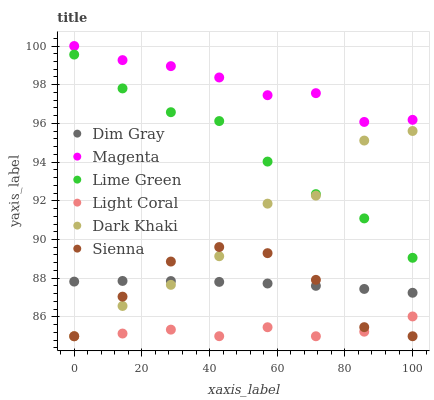Does Light Coral have the minimum area under the curve?
Answer yes or no. Yes. Does Magenta have the maximum area under the curve?
Answer yes or no. Yes. Does Dim Gray have the minimum area under the curve?
Answer yes or no. No. Does Dim Gray have the maximum area under the curve?
Answer yes or no. No. Is Dim Gray the smoothest?
Answer yes or no. Yes. Is Dark Khaki the roughest?
Answer yes or no. Yes. Is Light Coral the smoothest?
Answer yes or no. No. Is Light Coral the roughest?
Answer yes or no. No. Does Dark Khaki have the lowest value?
Answer yes or no. Yes. Does Dim Gray have the lowest value?
Answer yes or no. No. Does Magenta have the highest value?
Answer yes or no. Yes. Does Dim Gray have the highest value?
Answer yes or no. No. Is Light Coral less than Dim Gray?
Answer yes or no. Yes. Is Lime Green greater than Light Coral?
Answer yes or no. Yes. Does Dim Gray intersect Dark Khaki?
Answer yes or no. Yes. Is Dim Gray less than Dark Khaki?
Answer yes or no. No. Is Dim Gray greater than Dark Khaki?
Answer yes or no. No. Does Light Coral intersect Dim Gray?
Answer yes or no. No. 